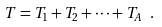Convert formula to latex. <formula><loc_0><loc_0><loc_500><loc_500>T = T _ { 1 } + T _ { 2 } + \dots + T _ { A } \ .</formula> 